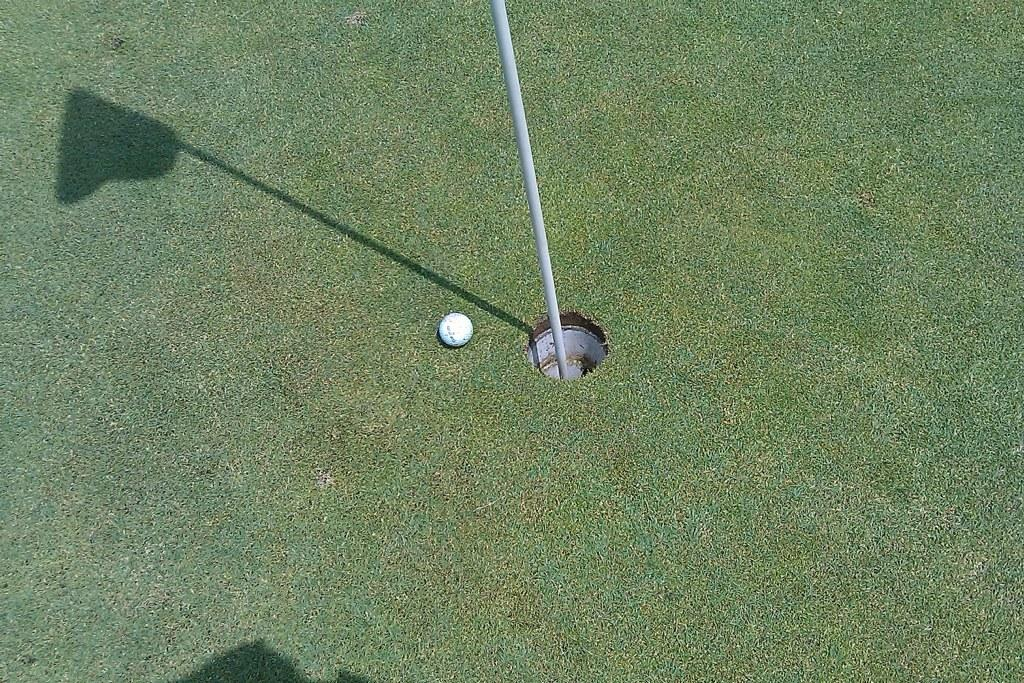What object is present on the grass in the image? There is a golf ball in the image. What is the golf ball resting on in the image? The golf ball is on the grass. What other object can be seen near the golf ball? There is a metal rod in the image. How is the metal rod positioned in relation to the golf ball? The metal rod is beside the golf ball. What type of vein can be seen running through the golf ball in the image? There are no veins present in the golf ball or the image; it is an inanimate object. What type of sand can be seen covering the metal rod in the image? There is no sand present in the image, and the metal rod is not covered in any substance. 